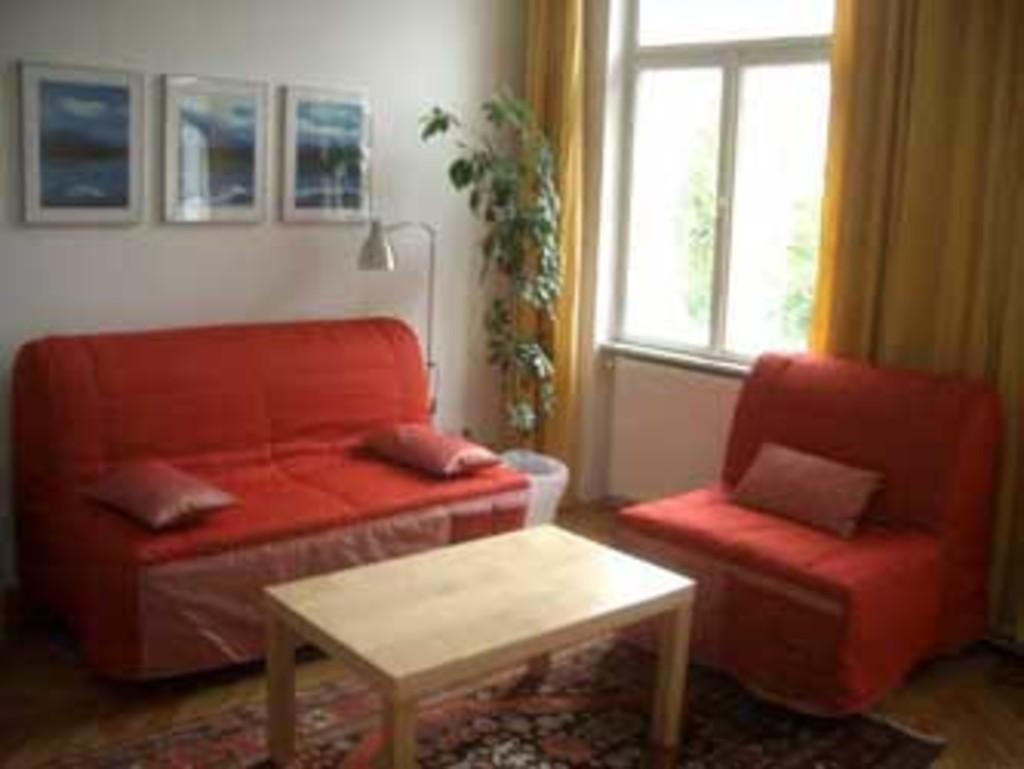What type of furniture is present in the image? There is a sofa set and a table in the image. What can be seen on the table? The image does not show any specific items on the table. What type of vegetation is present in the image? There is a plant in the image. What is visible in the background of the image? There is a wall, a window, and photo frames in the background of the image. What type of window treatment is present in the image? There are curtains associated with the window in the image. What type of tail can be seen on the sofa in the image? There is no tail present on the sofa in the image. What is the size of the stew in the image? There is no stew present in the image. 